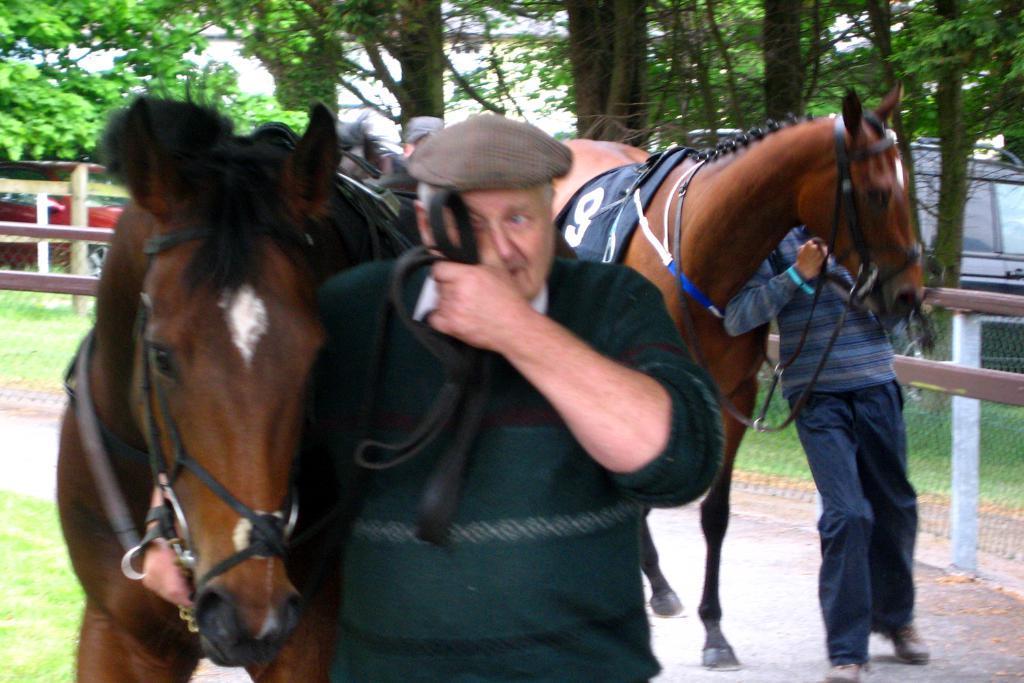In one or two sentences, can you explain what this image depicts? It is an outdoor picture where the person in the middle of the picture is wearing green shirt and cap and he is holding the horse, behind him there is another person holding the horse and backside of them there are so many trees and one vehicle. They are surrounded by the fence. 